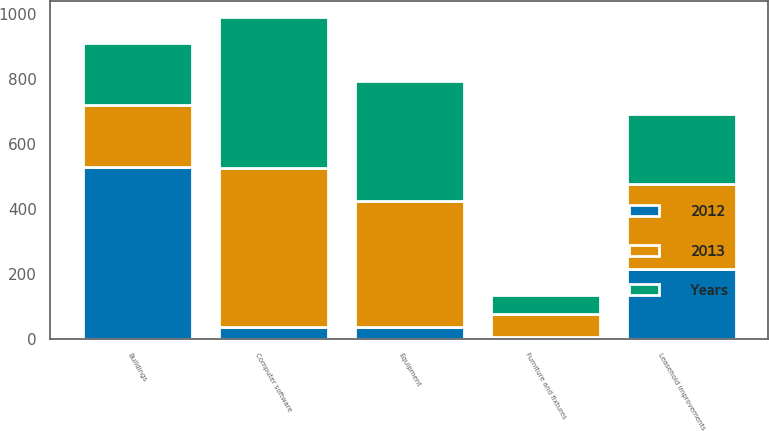Convert chart. <chart><loc_0><loc_0><loc_500><loc_500><stacked_bar_chart><ecel><fcel>Equipment<fcel>Computer software<fcel>Furniture and fixtures<fcel>Leasehold improvements<fcel>Buildings<nl><fcel>2012<fcel>35<fcel>36<fcel>5<fcel>216<fcel>530<nl><fcel>2013<fcel>388<fcel>489<fcel>72<fcel>262<fcel>191<nl><fcel>Years<fcel>370<fcel>466<fcel>59<fcel>213<fcel>191<nl></chart> 